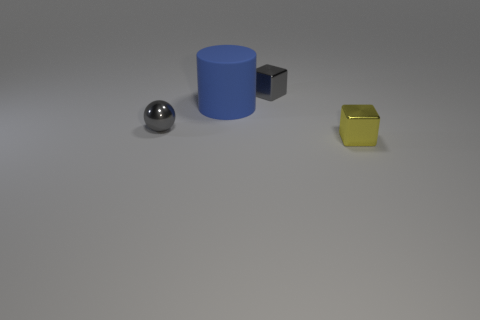What number of other objects are the same shape as the yellow object?
Offer a very short reply. 1. How many tiny objects are green matte balls or yellow cubes?
Your answer should be very brief. 1. Are there any big blue rubber things of the same shape as the small yellow object?
Your answer should be very brief. No. Is the shape of the tiny yellow metal object the same as the big blue matte object?
Provide a short and direct response. No. The block that is to the right of the block that is behind the small yellow metallic block is what color?
Ensure brevity in your answer.  Yellow. The metal block that is the same size as the yellow shiny thing is what color?
Offer a very short reply. Gray. What number of matte things are either blue things or small brown balls?
Offer a very short reply. 1. There is a gray thing in front of the gray metallic block; how many tiny gray metal spheres are in front of it?
Provide a succinct answer. 0. What is the size of the cube that is the same color as the shiny sphere?
Keep it short and to the point. Small. How many objects are small things or cubes that are to the left of the tiny yellow thing?
Provide a short and direct response. 3. 